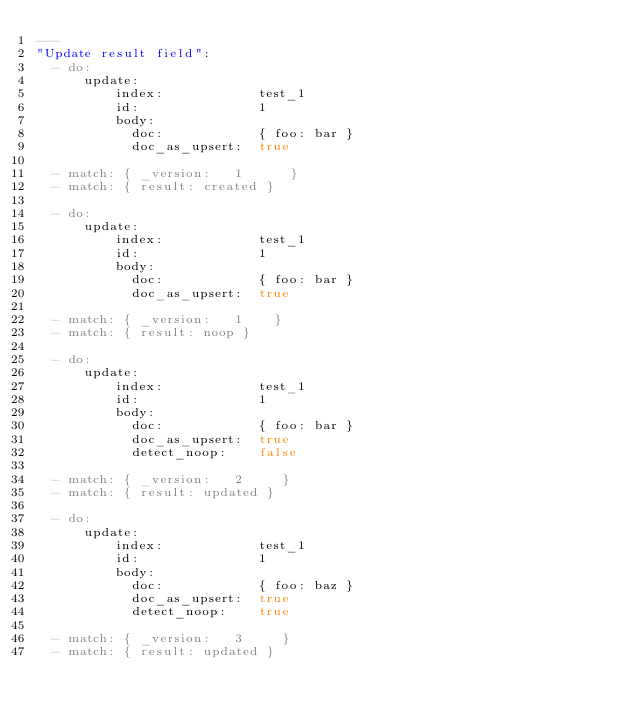Convert code to text. <code><loc_0><loc_0><loc_500><loc_500><_YAML_>---
"Update result field":
  - do:
      update:
          index:            test_1
          id:               1
          body:
            doc:            { foo: bar }
            doc_as_upsert:  true

  - match: { _version:   1      }
  - match: { result: created }

  - do:
      update:
          index:            test_1
          id:               1
          body:
            doc:            { foo: bar }
            doc_as_upsert:  true

  - match: { _version:   1    }
  - match: { result: noop }

  - do:
      update:
          index:            test_1
          id:               1
          body:
            doc:            { foo: bar }
            doc_as_upsert:  true
            detect_noop:    false

  - match: { _version:   2     }
  - match: { result: updated }

  - do:
      update:
          index:            test_1
          id:               1
          body:
            doc:            { foo: baz }
            doc_as_upsert:  true
            detect_noop:    true

  - match: { _version:   3     }
  - match: { result: updated }
</code> 